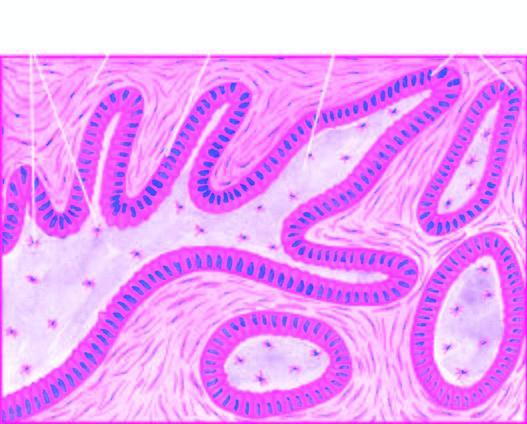re epithelial follicles composed of central area of stellate cells and peripheral layer of cuboidal or columnar cells?
Answer the question using a single word or phrase. Yes 